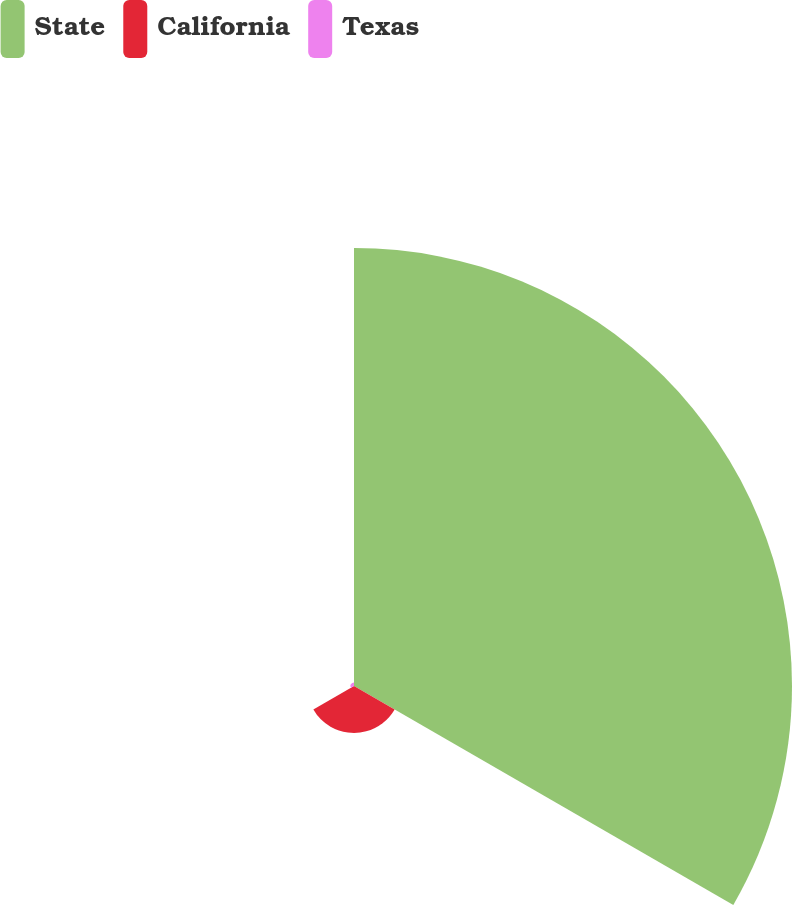Convert chart to OTSL. <chart><loc_0><loc_0><loc_500><loc_500><pie_chart><fcel>State<fcel>California<fcel>Texas<nl><fcel>89.68%<fcel>9.61%<fcel>0.71%<nl></chart> 